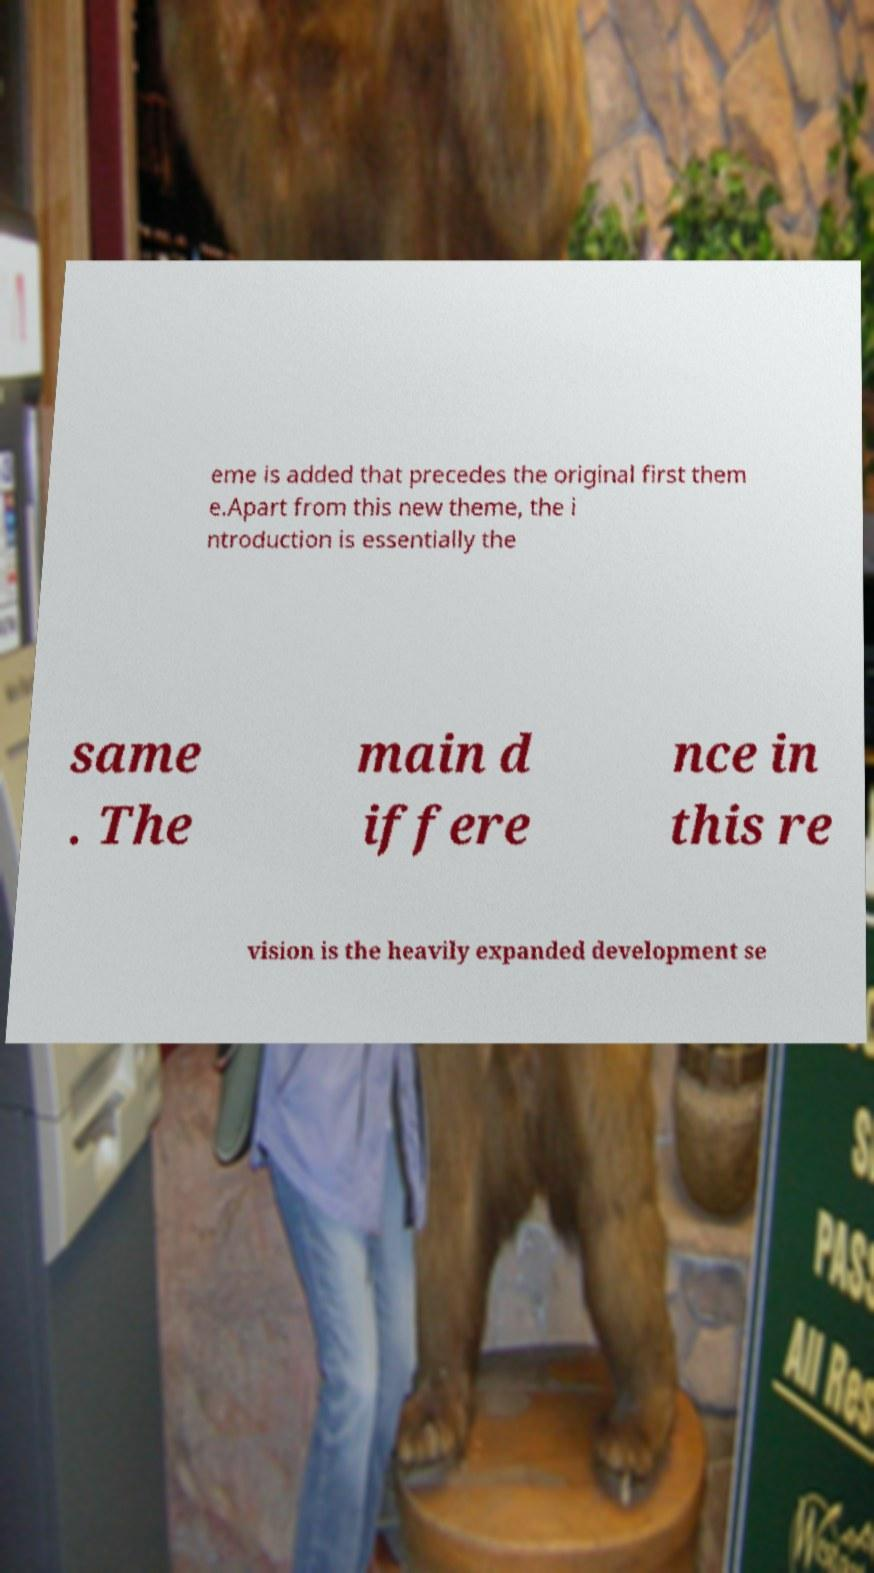Could you extract and type out the text from this image? eme is added that precedes the original first them e.Apart from this new theme, the i ntroduction is essentially the same . The main d iffere nce in this re vision is the heavily expanded development se 